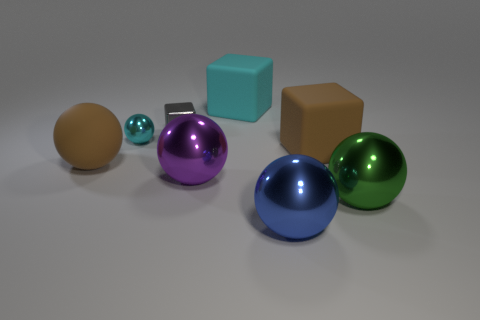Subtract all tiny shiny balls. How many balls are left? 4 Subtract all brown balls. How many balls are left? 4 Subtract all yellow spheres. Subtract all red cylinders. How many spheres are left? 5 Add 1 small purple rubber spheres. How many objects exist? 9 Add 2 brown matte balls. How many brown matte balls exist? 3 Subtract 0 red cylinders. How many objects are left? 8 Subtract all cubes. How many objects are left? 5 Subtract all rubber blocks. Subtract all purple spheres. How many objects are left? 5 Add 4 big brown matte balls. How many big brown matte balls are left? 5 